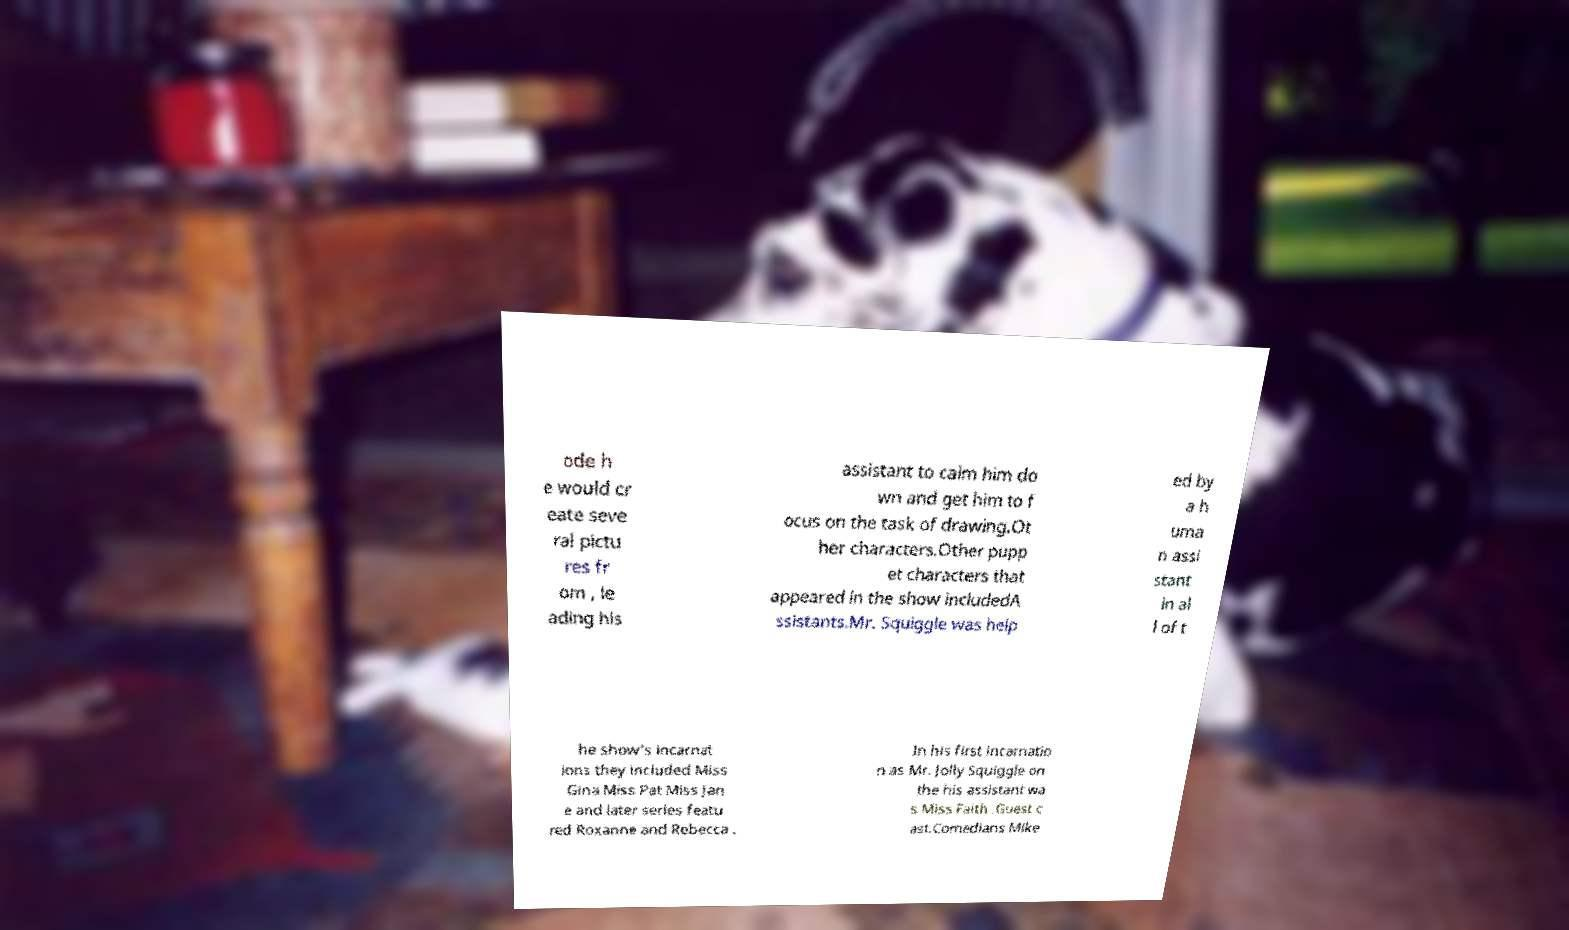Please identify and transcribe the text found in this image. ode h e would cr eate seve ral pictu res fr om , le ading his assistant to calm him do wn and get him to f ocus on the task of drawing.Ot her characters.Other pupp et characters that appeared in the show includedA ssistants.Mr. Squiggle was help ed by a h uma n assi stant in al l of t he show's incarnat ions they included Miss Gina Miss Pat Miss Jan e and later series featu red Roxanne and Rebecca . In his first incarnatio n as Mr. Jolly Squiggle on the his assistant wa s Miss Faith .Guest c ast.Comedians Mike 